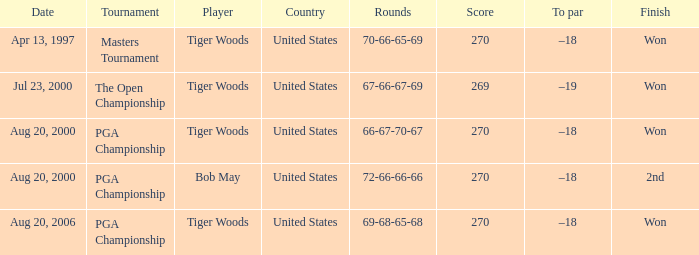Would you mind parsing the complete table? {'header': ['Date', 'Tournament', 'Player', 'Country', 'Rounds', 'Score', 'To par', 'Finish'], 'rows': [['Apr 13, 1997', 'Masters Tournament', 'Tiger Woods', 'United States', '70-66-65-69', '270', '–18', 'Won'], ['Jul 23, 2000', 'The Open Championship', 'Tiger Woods', 'United States', '67-66-67-69', '269', '–19', 'Won'], ['Aug 20, 2000', 'PGA Championship', 'Tiger Woods', 'United States', '66-67-70-67', '270', '–18', 'Won'], ['Aug 20, 2000', 'PGA Championship', 'Bob May', 'United States', '72-66-66-66', '270', '–18', '2nd'], ['Aug 20, 2006', 'PGA Championship', 'Tiger Woods', 'United States', '69-68-65-68', '270', '–18', 'Won']]} What is the worst (highest) score? 270.0. 